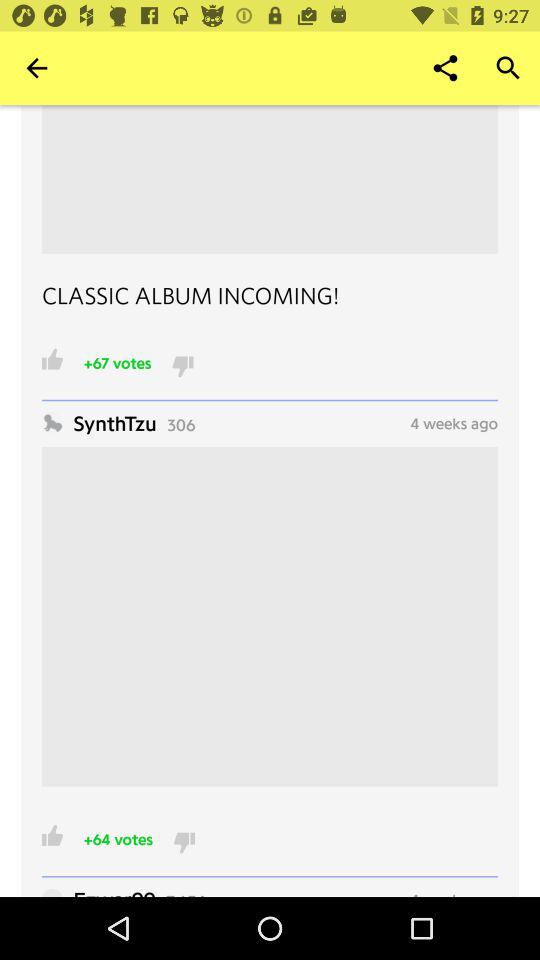When was the post posted? The post was posted 4 weeks ago. 